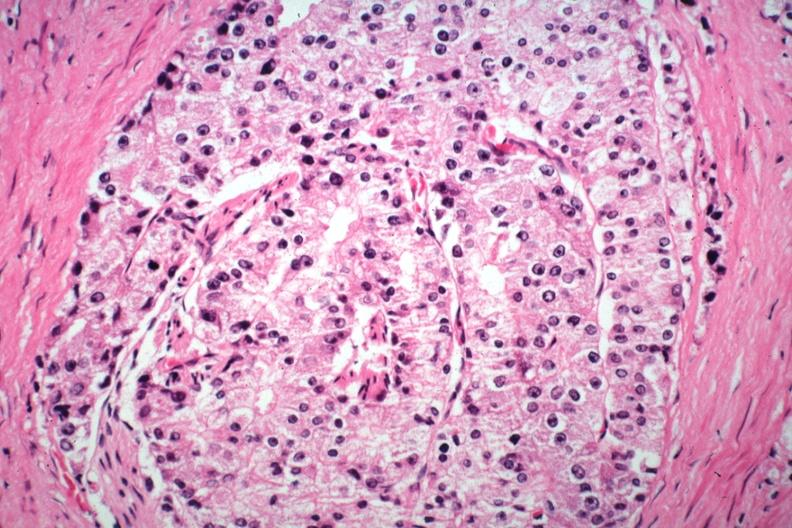what is present?
Answer the question using a single word or phrase. Adenocarcinoma 